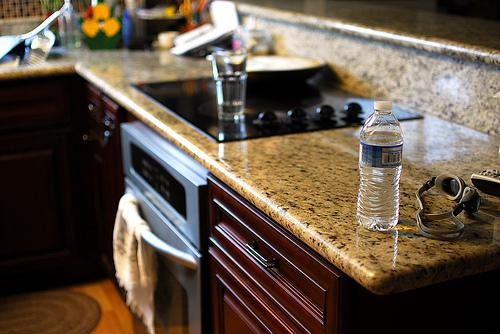Question: where is the towel hanging?
Choices:
A. On the wall.
B. From the drawer.
C. On the sink.
D. On the oven handle.
Answer with the letter. Answer: D Question: how many bottles of water are there?
Choices:
A. Two.
B. Three.
C. Four.
D. One.
Answer with the letter. Answer: D Question: what is on the floor?
Choices:
A. A decorative pattern.
B. A rug.
C. Wood grain.
D. Directional arrows.
Answer with the letter. Answer: B Question: what is on the right of the goggles?
Choices:
A. A cellphone.
B. A remote.
C. A glass.
D. A cup.
Answer with the letter. Answer: B 